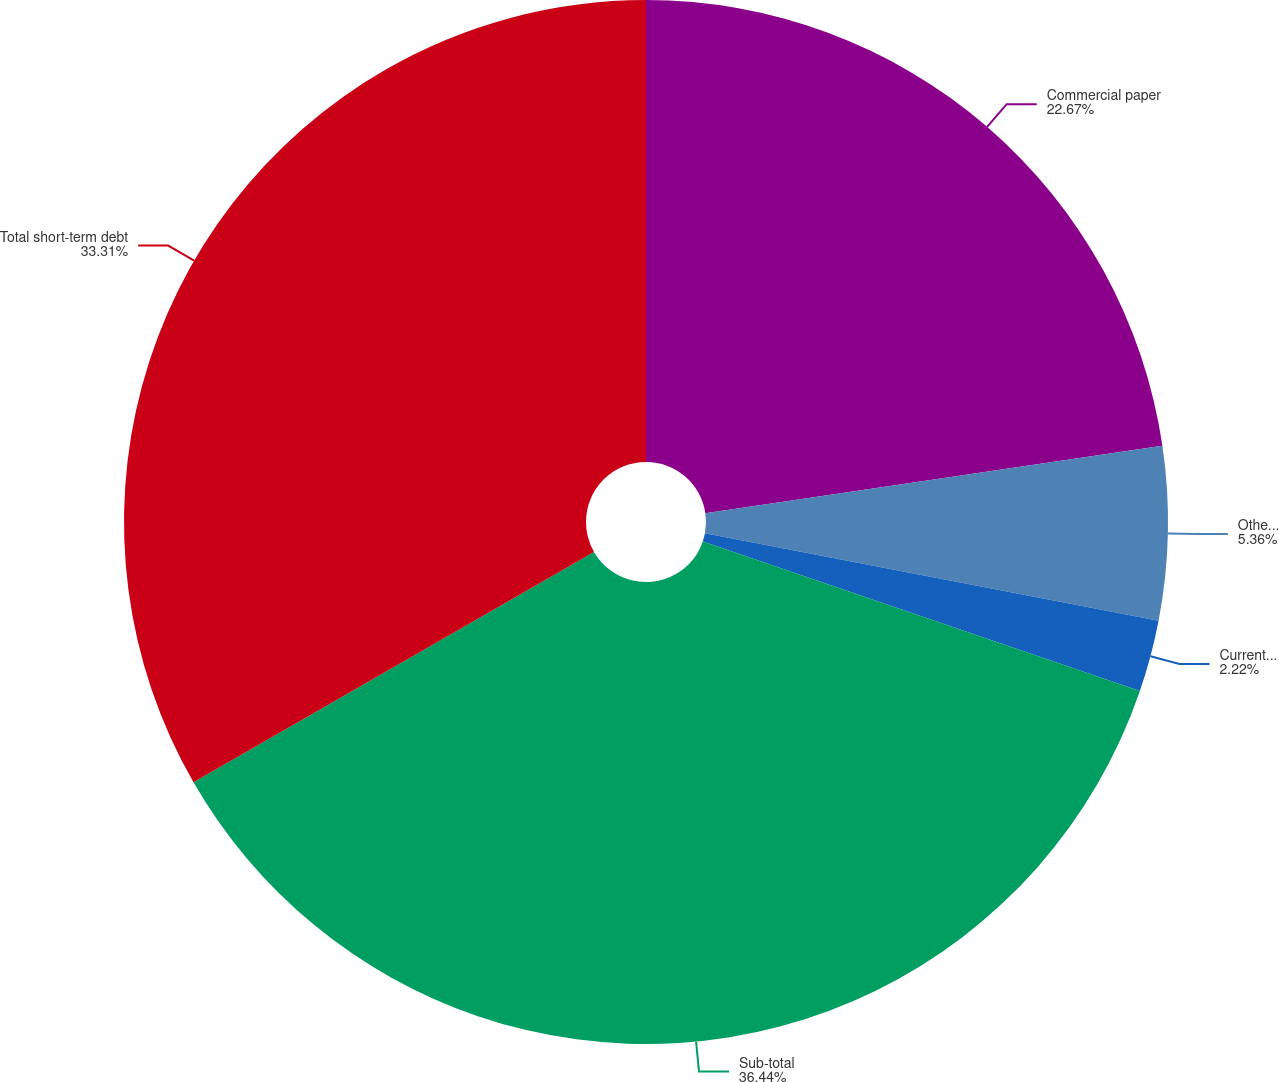Convert chart. <chart><loc_0><loc_0><loc_500><loc_500><pie_chart><fcel>Commercial paper<fcel>Other notes payable<fcel>Current portion of long-term<fcel>Sub-total<fcel>Total short-term debt<nl><fcel>22.67%<fcel>5.36%<fcel>2.22%<fcel>36.45%<fcel>33.31%<nl></chart> 